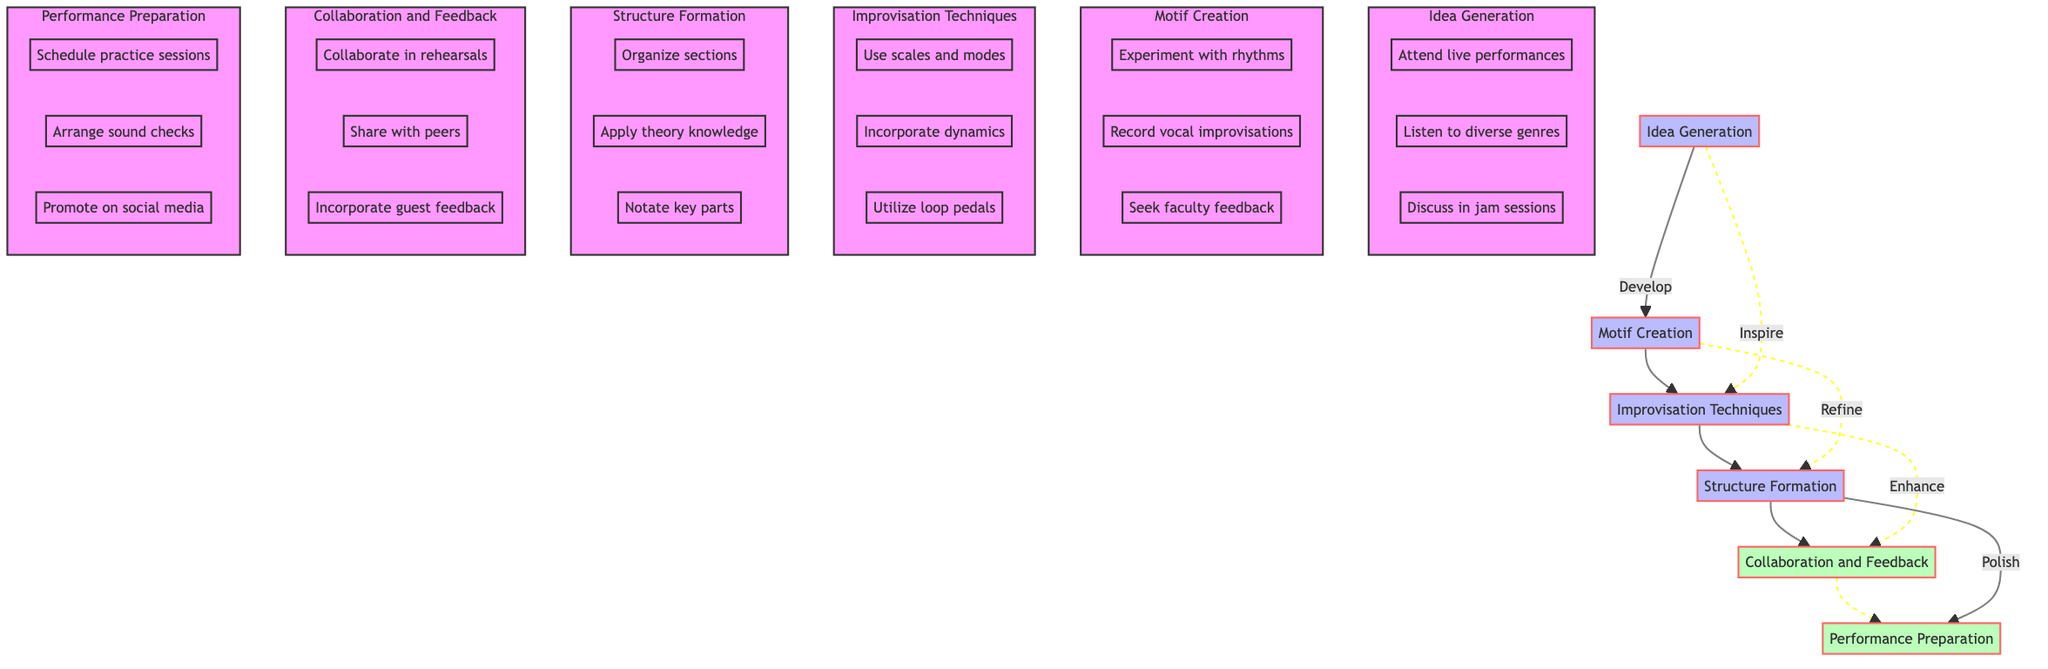What is the final step in the creative process? The final step in the creative process as shown in the diagram is "Performance Preparation," which is the last node in the flow.
Answer: Performance Preparation How many main steps are there in the process? The diagram has six main steps: Idea Generation, Motif Creation, Improvisation Techniques, Structure Formation, Collaboration and Feedback, and Performance Preparation.
Answer: Six Which step comes after "Motif Creation"? The diagram indicates that "Improvisation Techniques" follows "Motif Creation." There is a direct arrow leading from Motif Creation to Improvisation Techniques.
Answer: Improvisation Techniques What type of feedback is sought during "Collaboration and Feedback"? "Collaboration and Feedback" involves seeking constructive criticism from peers and incorporating feedback from guest artist workshops.
Answer: Constructive criticism What is used to enhance motifs after improvisation techniques? After the "Improvisation Techniques," the next step involves enhancing the piece through "Collaboration and Feedback." This indicates collaboration as a means of enhancement.
Answer: Collaboration How many steps involve experimentation? The steps that involve experimentation are under "Idea Generation" and "Motif Creation." In total, there are three experiments listed: attending live performances, experimenting with rhythms, and recording vocal improvisations, meaning a total of three.
Answer: Three What is one of the actions taken during "Performance Preparation"? One action during "Performance Preparation" is to "Schedule practice sessions," indicating preparation activities before the live performance.
Answer: Schedule practice sessions Which step includes applying theory knowledge? "Structure Formation" is the step that includes applying theory knowledge to create transitions in the composition, as outlined in the diagram.
Answer: Structure Formation How are improvisation techniques described in the diagram? The improvisation techniques are described as employing techniques to expand on motifs, showcasing how they build upon the initial musical ideas.
Answer: Employ techniques to expand on motifs 